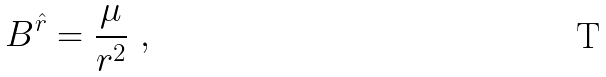<formula> <loc_0><loc_0><loc_500><loc_500>B ^ { \hat { r } } = \frac { \mu } { r ^ { 2 } } \ ,</formula> 